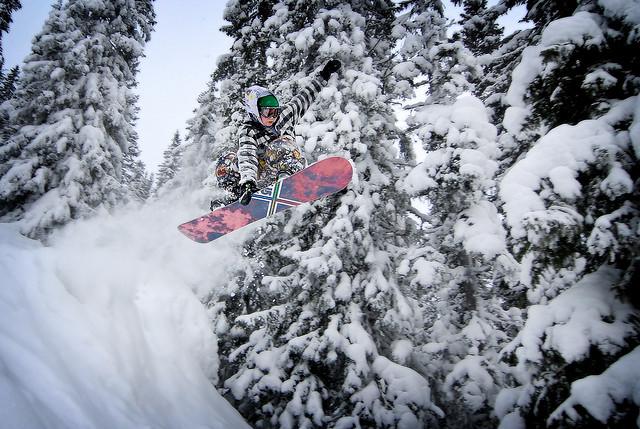Is this person a professional rider?
Answer briefly. Yes. Is the athlete snowboarding or skiing?
Be succinct. Snowboarding. Is there snow on the trees?
Keep it brief. Yes. 